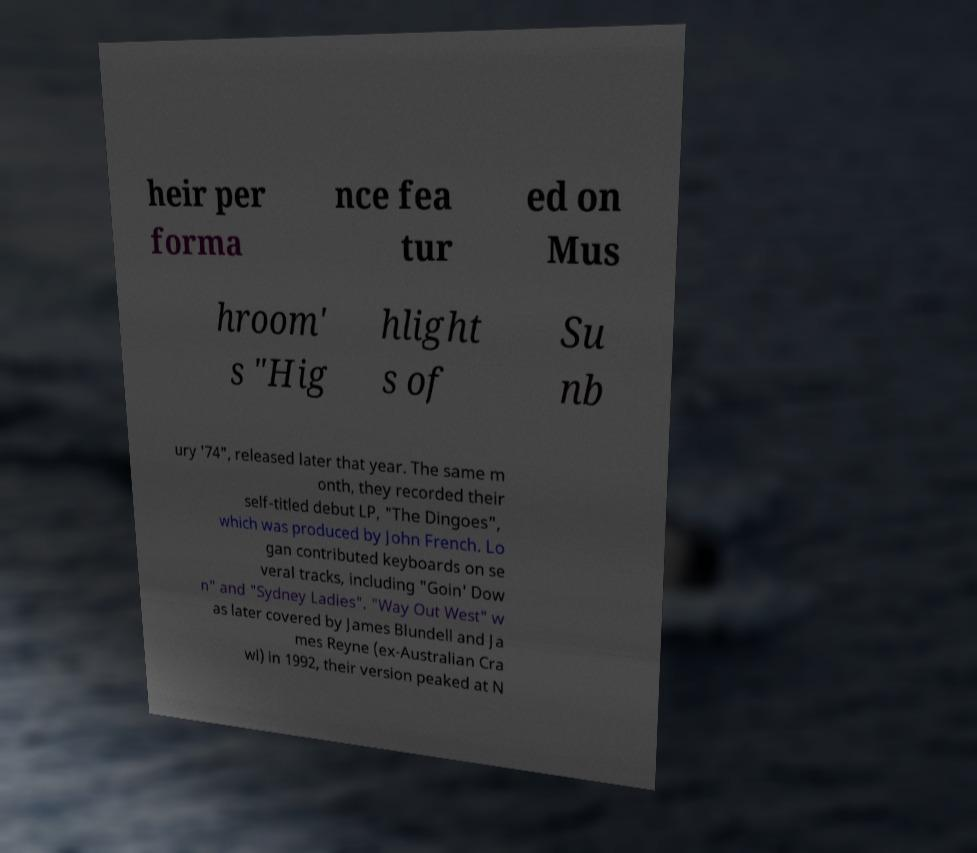Could you extract and type out the text from this image? heir per forma nce fea tur ed on Mus hroom' s "Hig hlight s of Su nb ury '74", released later that year. The same m onth, they recorded their self-titled debut LP, "The Dingoes", which was produced by John French. Lo gan contributed keyboards on se veral tracks, including "Goin' Dow n" and "Sydney Ladies". "Way Out West" w as later covered by James Blundell and Ja mes Reyne (ex-Australian Cra wl) in 1992, their version peaked at N 